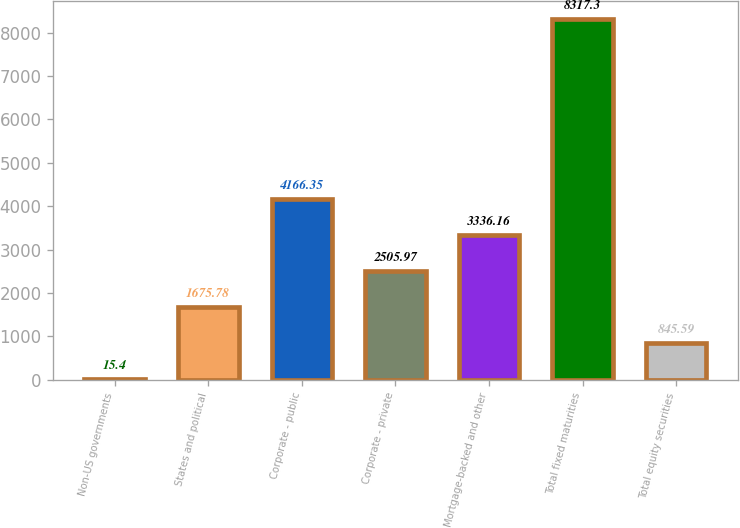Convert chart to OTSL. <chart><loc_0><loc_0><loc_500><loc_500><bar_chart><fcel>Non-US governments<fcel>States and political<fcel>Corporate - public<fcel>Corporate - private<fcel>Mortgage-backed and other<fcel>Total fixed maturities<fcel>Total equity securities<nl><fcel>15.4<fcel>1675.78<fcel>4166.35<fcel>2505.97<fcel>3336.16<fcel>8317.3<fcel>845.59<nl></chart> 